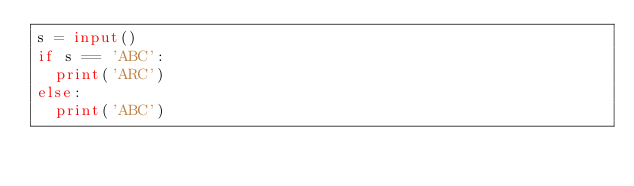<code> <loc_0><loc_0><loc_500><loc_500><_Python_>s = input()
if s == 'ABC':
  print('ARC')
else:
  print('ABC')</code> 